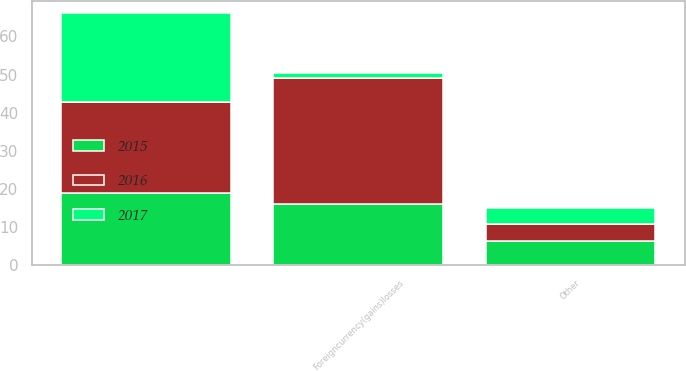Convert chart. <chart><loc_0><loc_0><loc_500><loc_500><stacked_bar_chart><ecel><fcel>Foreigncurrency(gains)losses<fcel>Unnamed: 2<fcel>Other<nl><fcel>2017<fcel>1.3<fcel>23.3<fcel>4.1<nl><fcel>2016<fcel>32.9<fcel>23.8<fcel>4.6<nl><fcel>2015<fcel>16.1<fcel>19<fcel>6.3<nl></chart> 